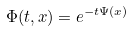Convert formula to latex. <formula><loc_0><loc_0><loc_500><loc_500>\Phi ( t , x ) = e ^ { - t \Psi ( x ) }</formula> 